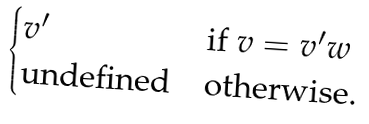<formula> <loc_0><loc_0><loc_500><loc_500>\begin{cases} v ^ { \prime } & \text {if } v = v ^ { \prime } w \\ \text {undefined} & \text {otherwise.} \end{cases}</formula> 